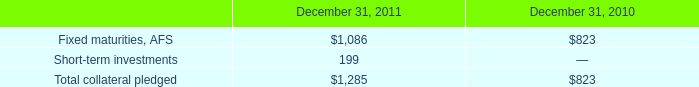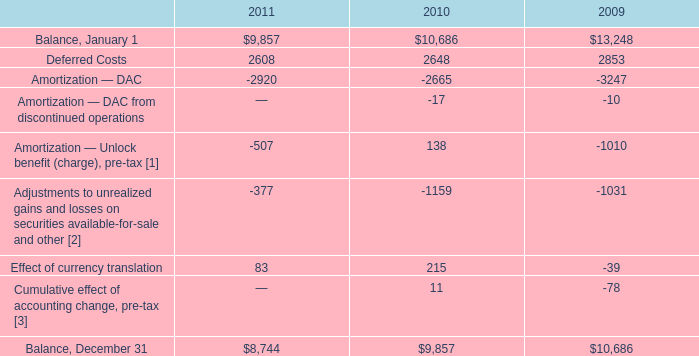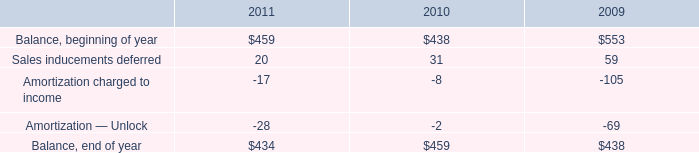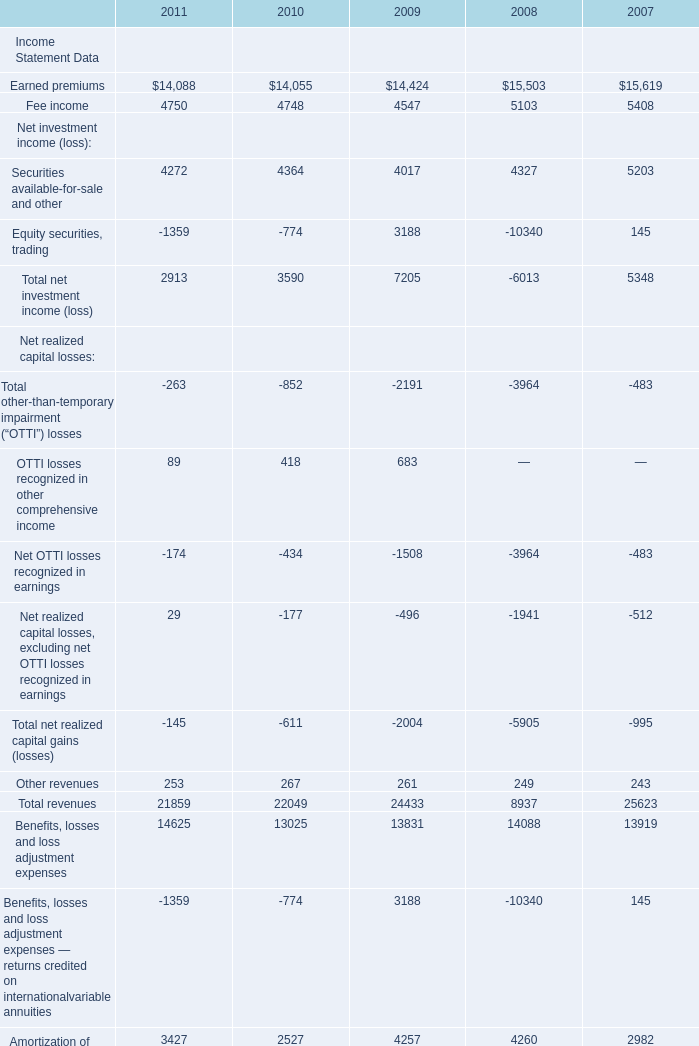what is the change in fair value of securities on deposits from 2010 to 2011 , ( in billions ) ? 
Computations: (1.6 - 1.4)
Answer: 0.2. 